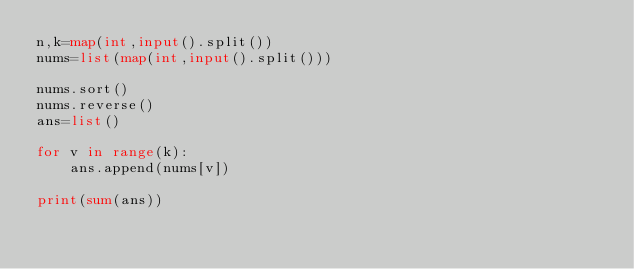<code> <loc_0><loc_0><loc_500><loc_500><_Python_>n,k=map(int,input().split())
nums=list(map(int,input().split()))

nums.sort()
nums.reverse()
ans=list()

for v in range(k):
    ans.append(nums[v])

print(sum(ans))</code> 